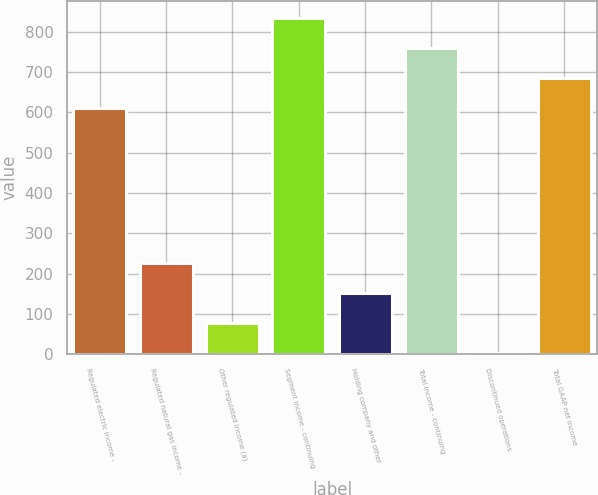<chart> <loc_0><loc_0><loc_500><loc_500><bar_chart><fcel>Regulated electric income -<fcel>Regulated natural gas income -<fcel>Other regulated income (a)<fcel>Segment income - continuing<fcel>Holding company and other<fcel>Total income - continuing<fcel>Discontinued operations<fcel>Total GAAP net income<nl><fcel>611.9<fcel>227.62<fcel>78.94<fcel>834.92<fcel>153.28<fcel>760.58<fcel>4.6<fcel>686.24<nl></chart> 